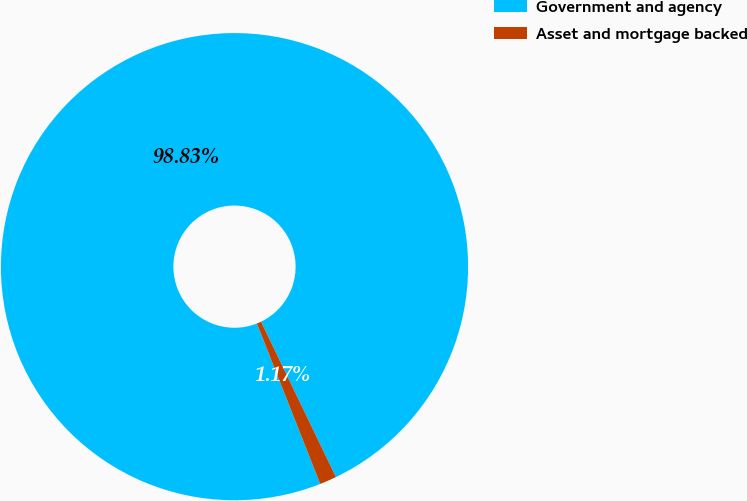<chart> <loc_0><loc_0><loc_500><loc_500><pie_chart><fcel>Government and agency<fcel>Asset and mortgage backed<nl><fcel>98.83%<fcel>1.17%<nl></chart> 